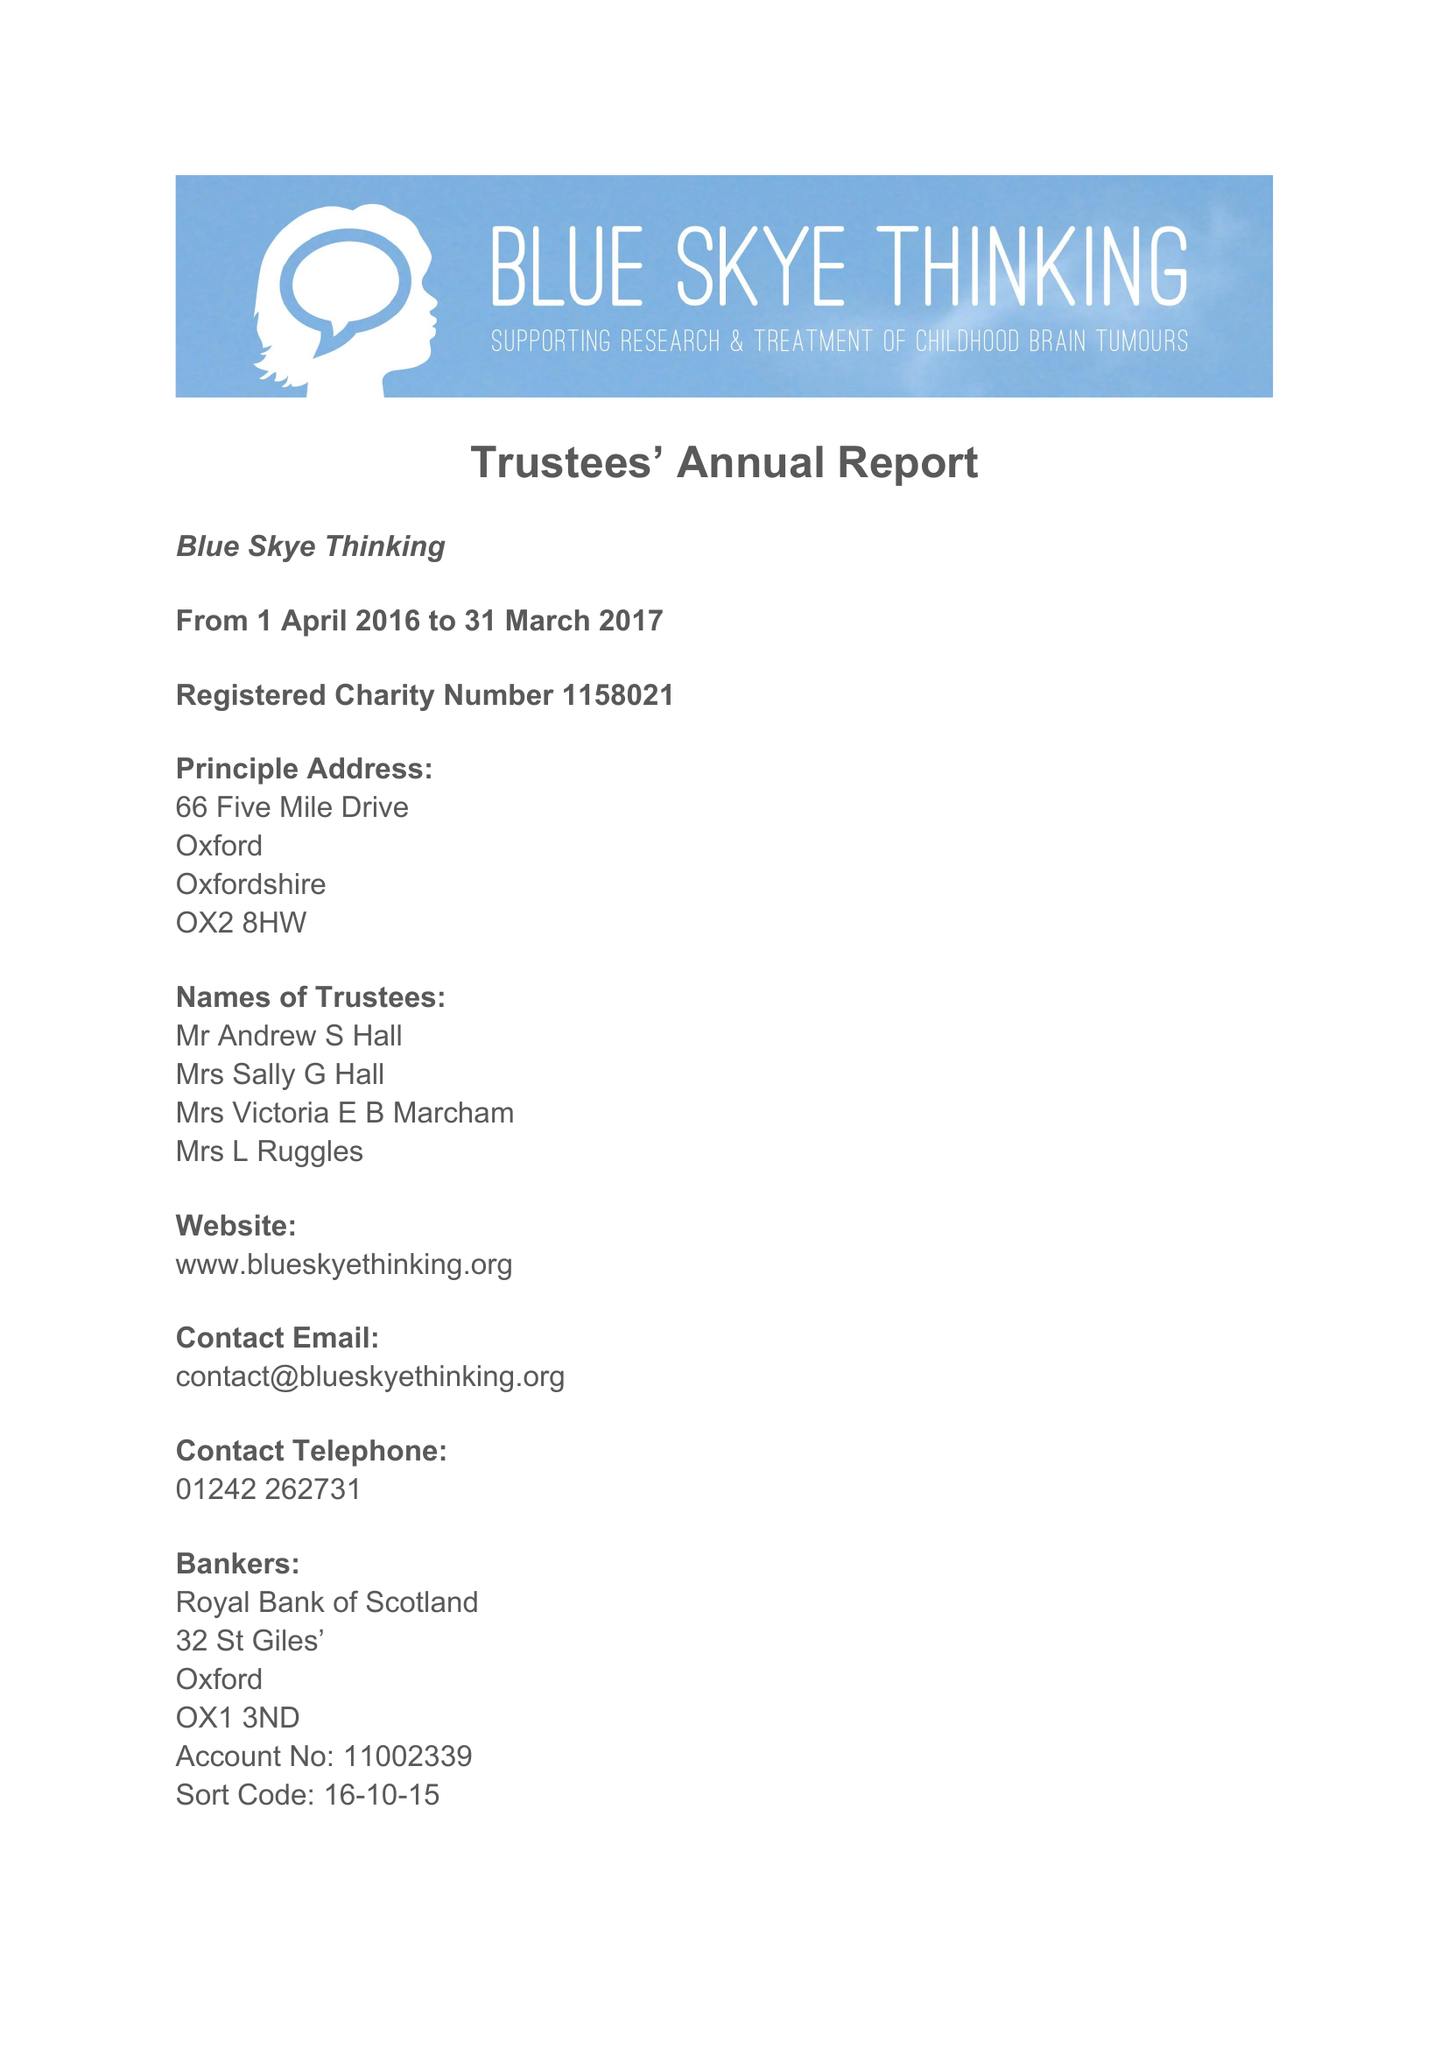What is the value for the charity_number?
Answer the question using a single word or phrase. 1158021 